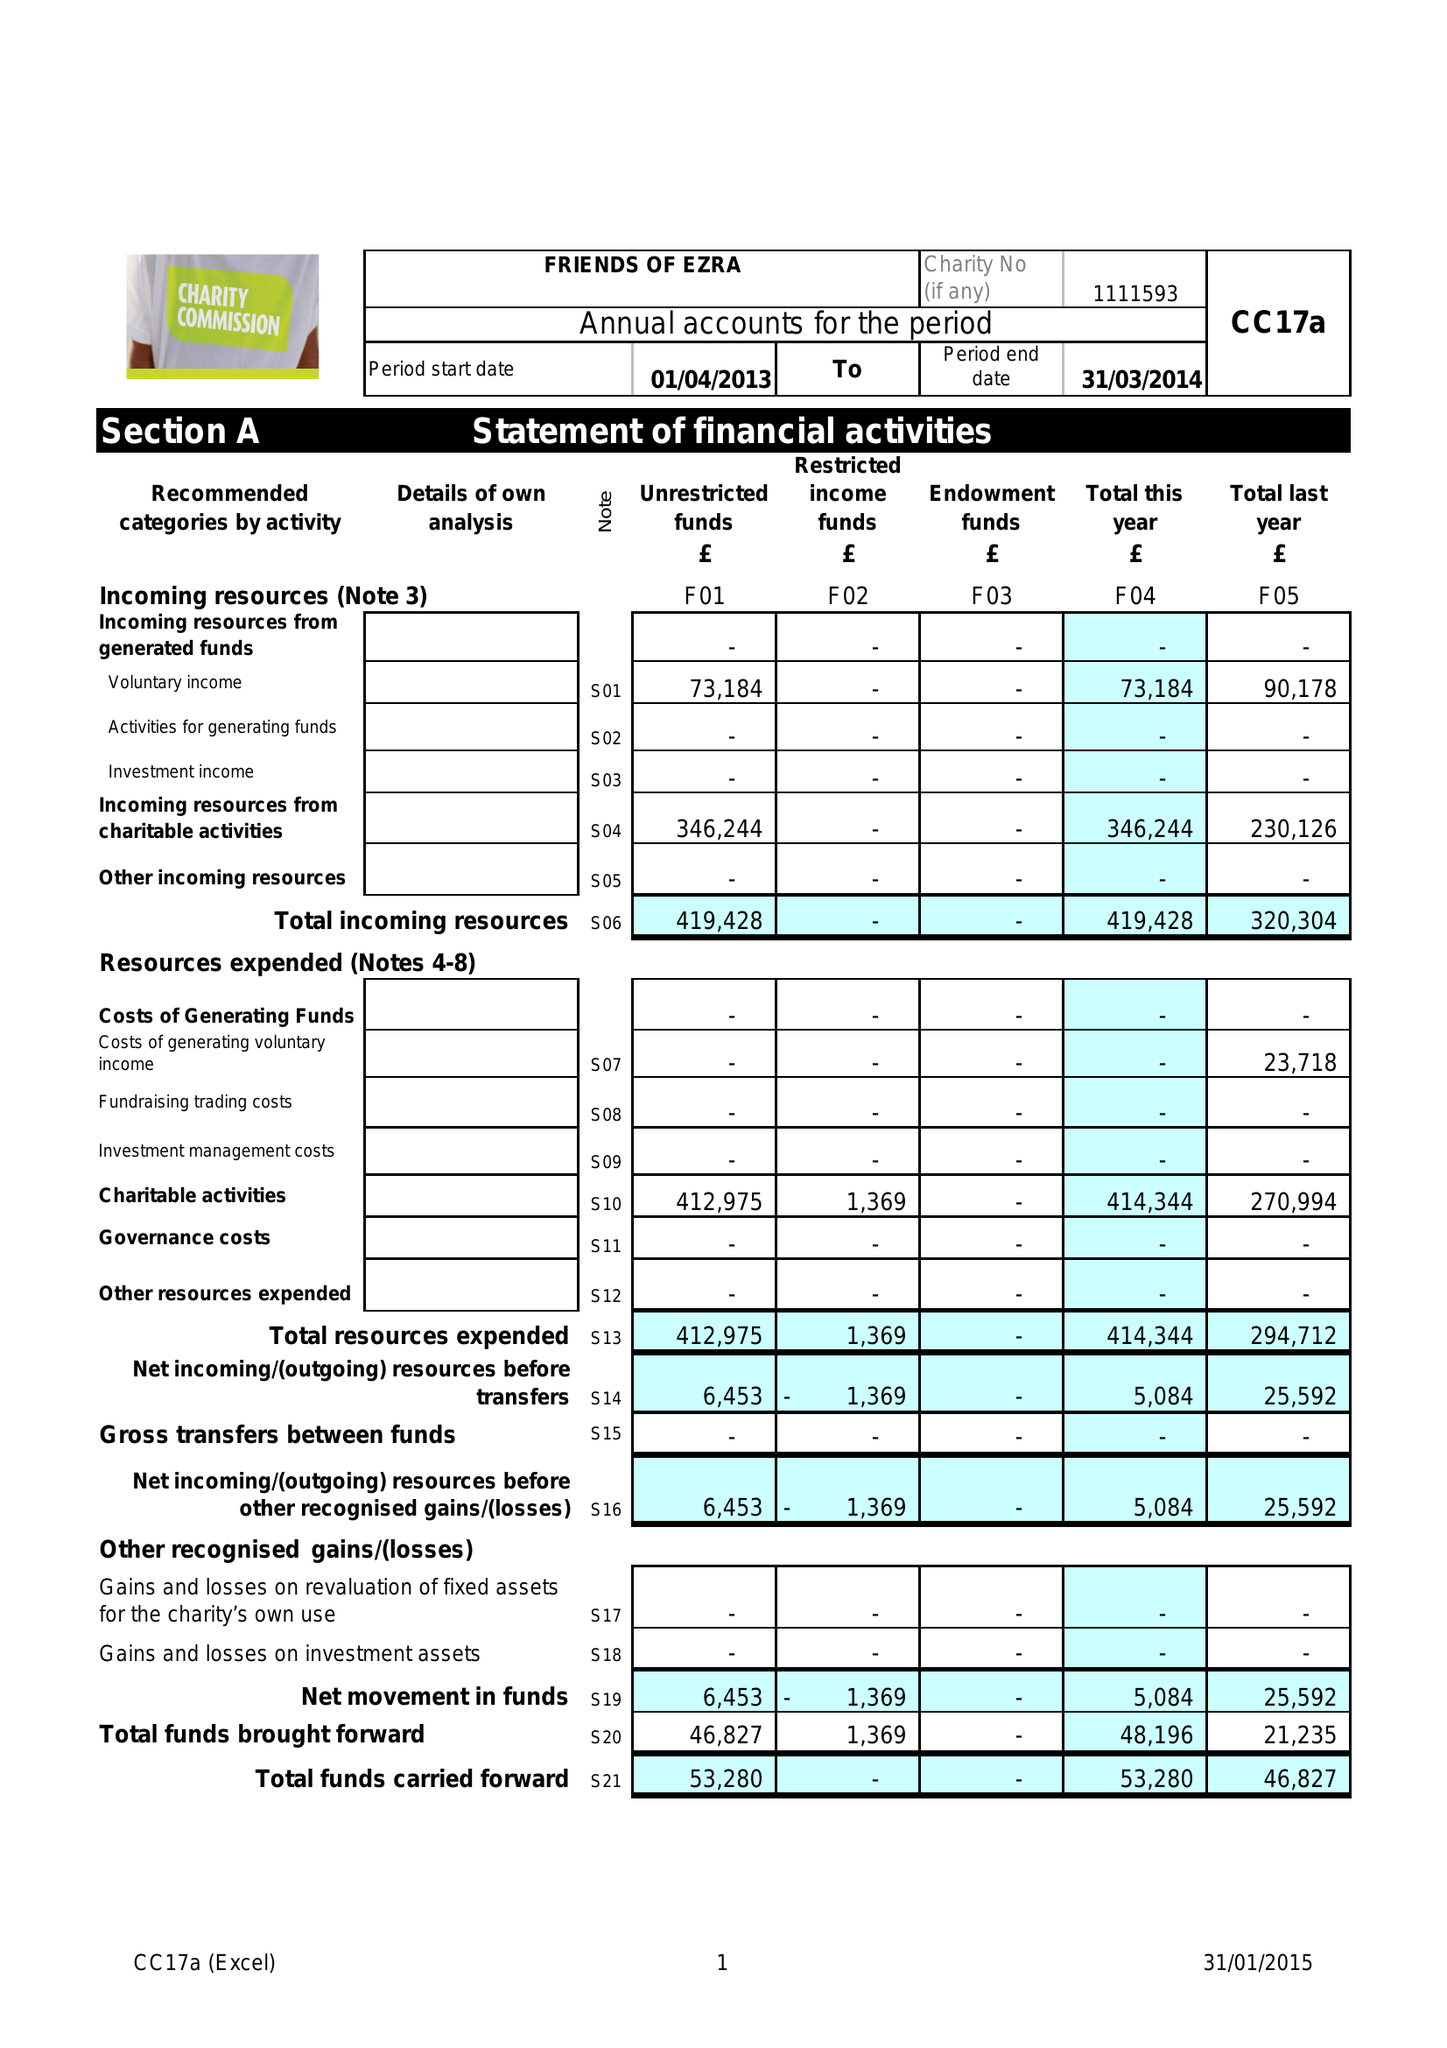What is the value for the address__postcode?
Answer the question using a single word or phrase. NW11 9BP 